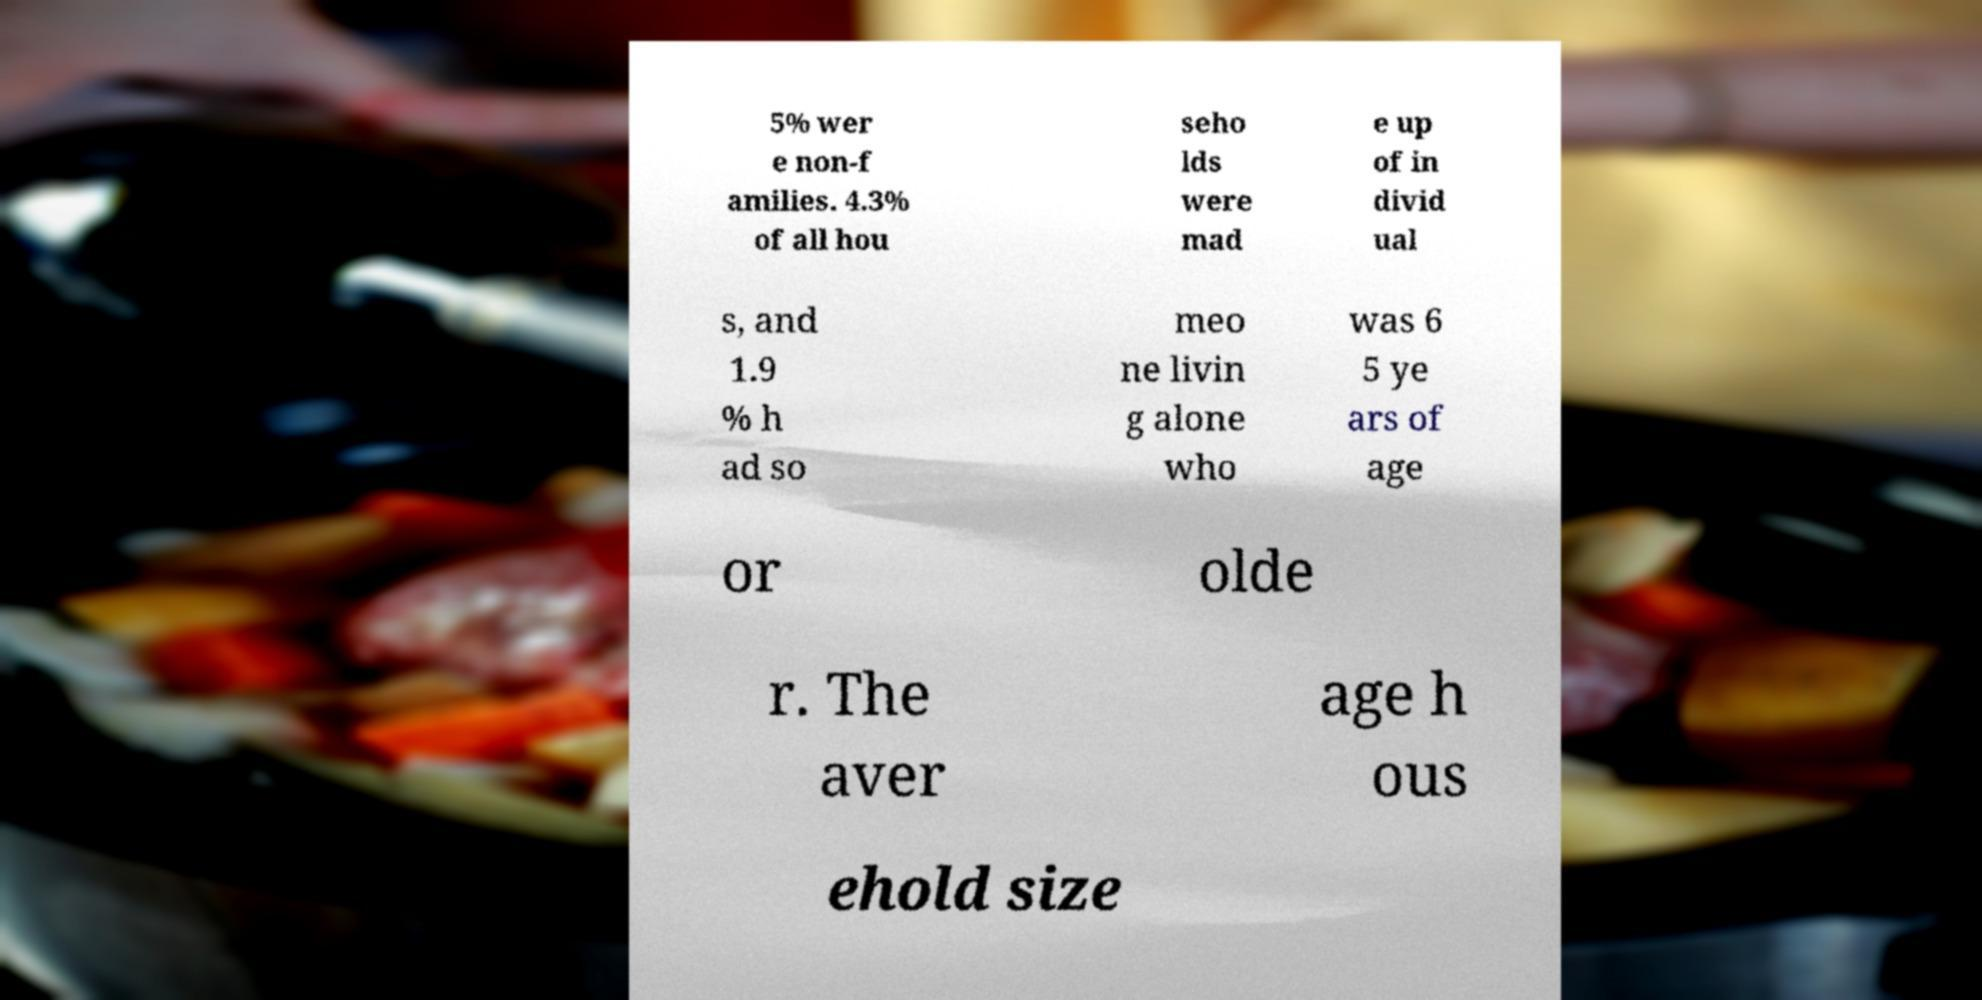Could you extract and type out the text from this image? 5% wer e non-f amilies. 4.3% of all hou seho lds were mad e up of in divid ual s, and 1.9 % h ad so meo ne livin g alone who was 6 5 ye ars of age or olde r. The aver age h ous ehold size 